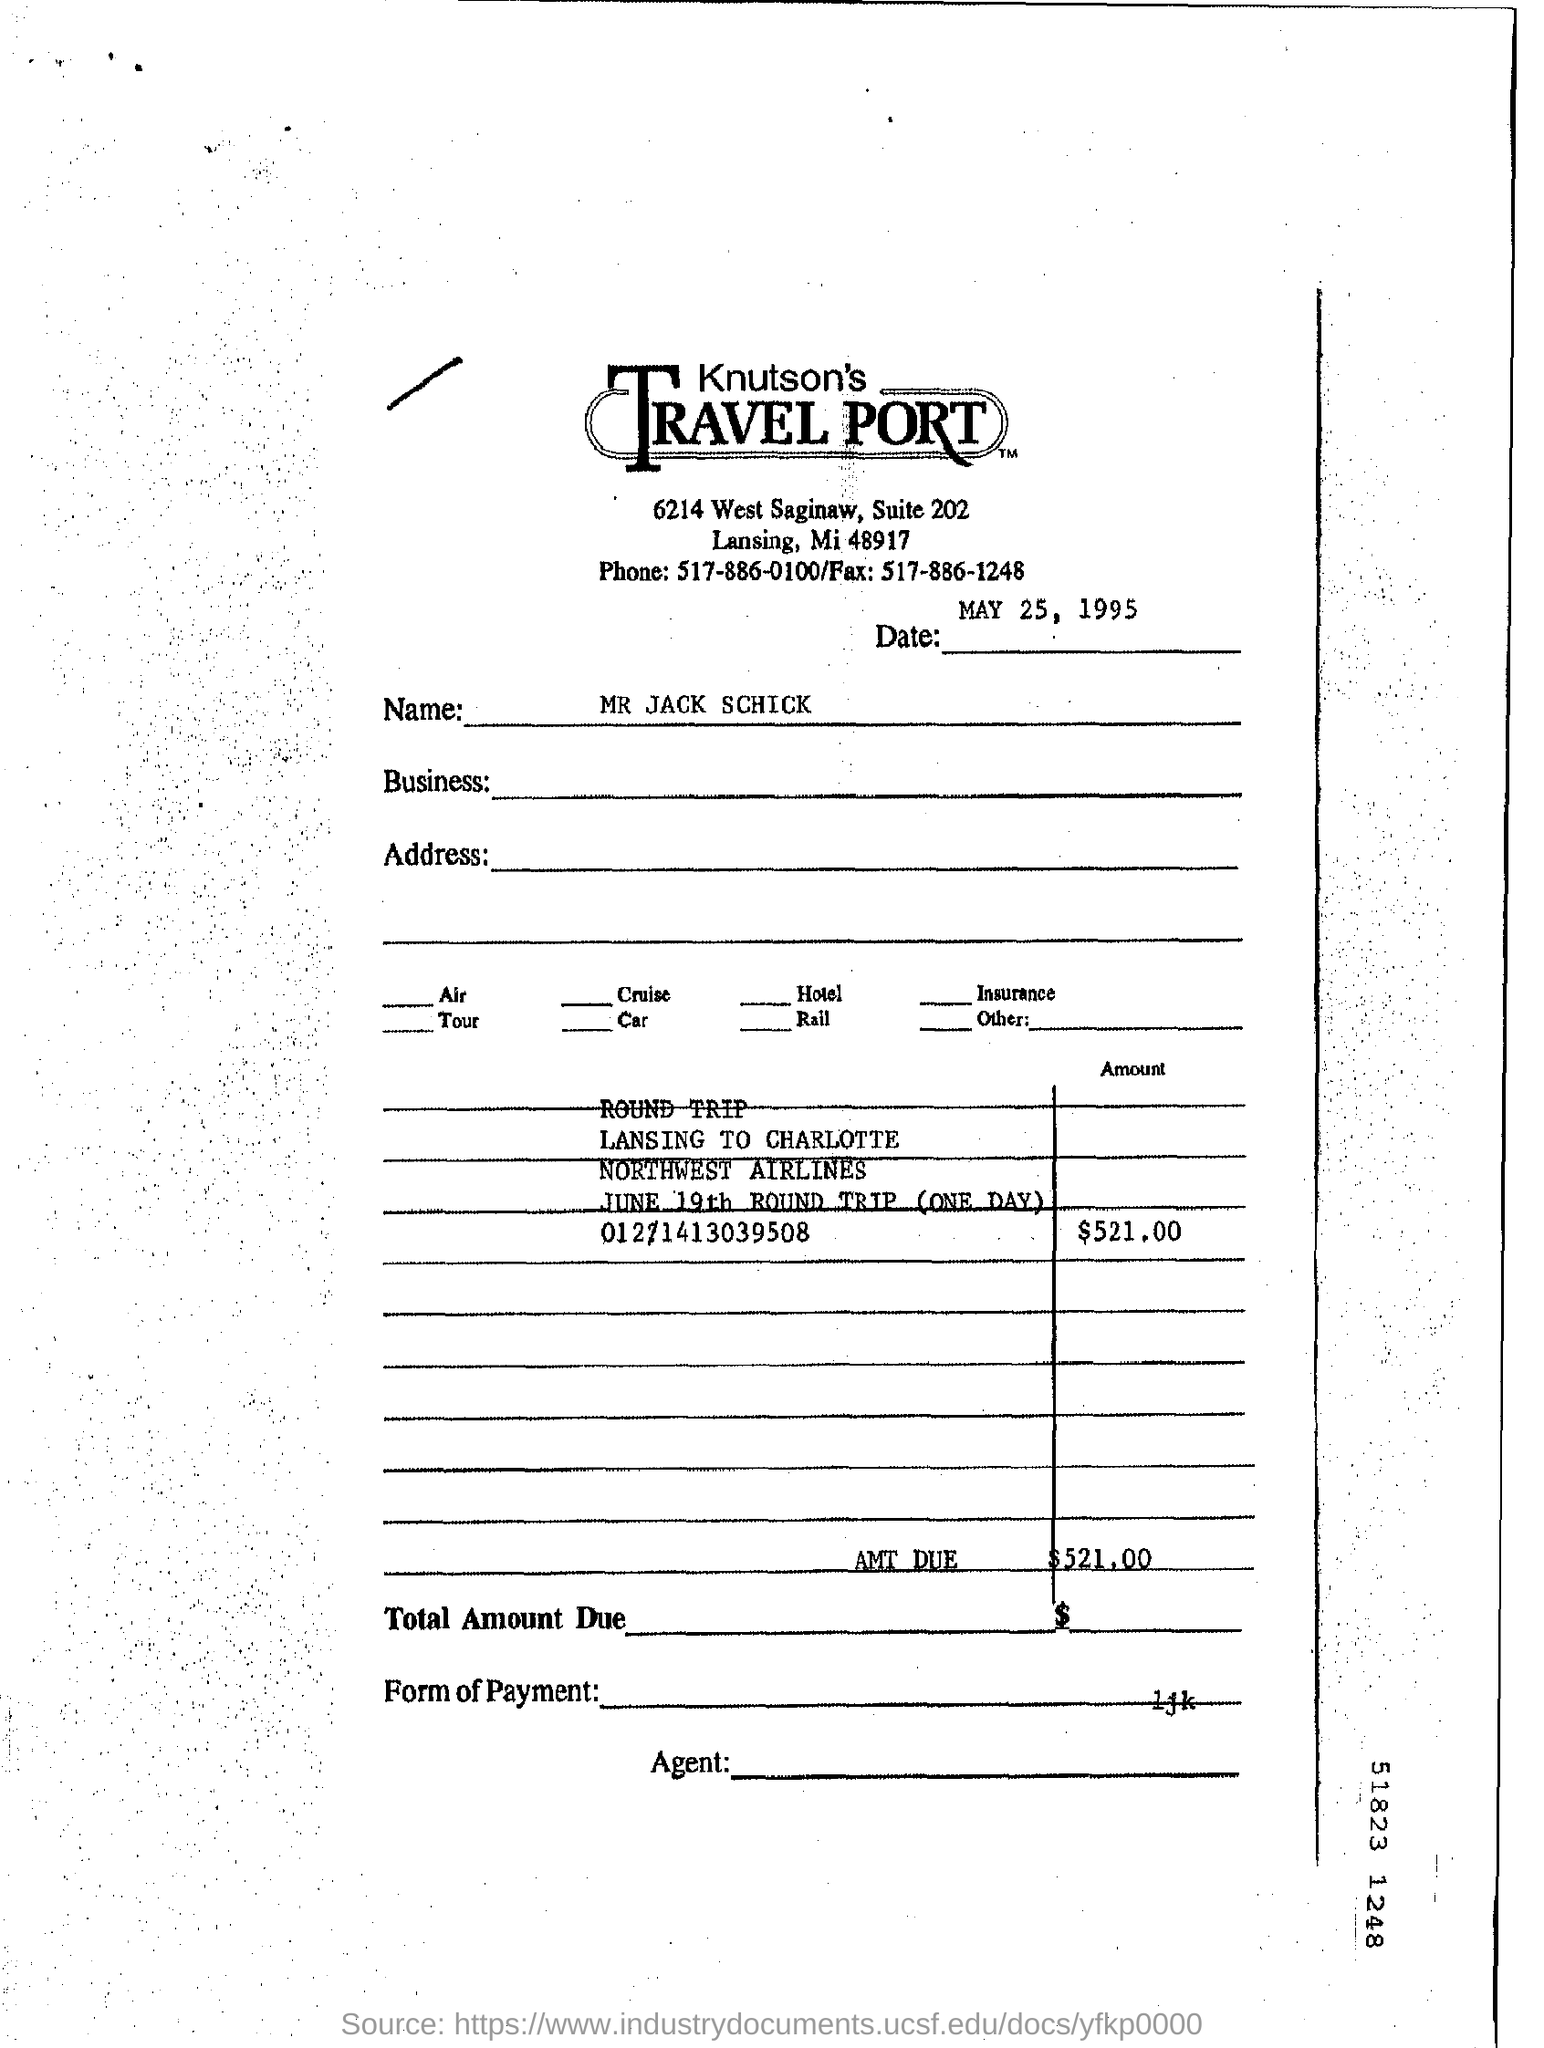What is the Suite Number ?
Your response must be concise. 202. What is the Fax Number ?
Make the answer very short. 517-886-1248. What is the date mentioned in the top of the document ?
Make the answer very short. MAY 25, 1995. Who's name written in the document ?
Keep it short and to the point. MR JACK SCHICK. How much Amount Due ?
Offer a very short reply. $521.00. What is the Phone Number ?
Your answer should be compact. 517-886-0100. 